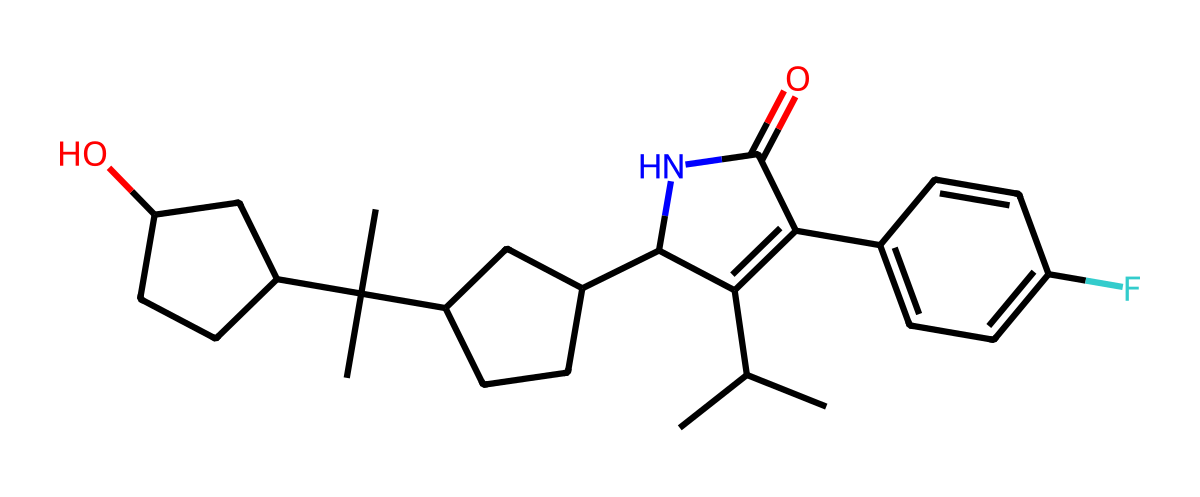What is the primary functional group in this molecule? The molecule contains an amide functional group as indicated by the presence of a carbonyl group (C=O) directly bonded to a nitrogen atom (N). This structural feature is characteristic of amides.
Answer: amide How many rings are present in the molecule? By analyzing the structure, there are three distinct ring systems evident in the chemical structure, which can be identified by the interconnected carbon atoms that form closed loops.
Answer: three What is the molecular formula of the chemical represented by the SMILES? To derive the molecular formula, we count the number of each type of atom in the SMILES representation. The structure contains 28 carbon atoms, 39 hydrogen atoms, 3 nitrogen atoms, 1 oxygen atom, and 1 fluorine atom, providing a molecular formula of C28H39N3O1F1.
Answer: C28H39N3OF Which part of the molecule is likely responsible for cholesterol-lowering activity? The portion of the molecule containing the hydroxyl group (the –OH) is generally associated with the cholesterol-lowering activity as it can interact with biological systems and inhibit HMG-CoA reductase, a key enzyme in cholesterol synthesis.
Answer: hydroxyl group Does this molecule contain any halogens? By examining the chemical structure, there is a fluorine atom present, which is a halogen. This indicates that the compound does indeed contain halogens.
Answer: yes What type of stereochemistry does this molecule exhibit? The structure shows multiple chiral centers, indicated by the presence of carbon atoms bonded to four different substituents, resulting in the possibility of stereoisomers due to the spatial arrangement at these centers.
Answer: chiral 